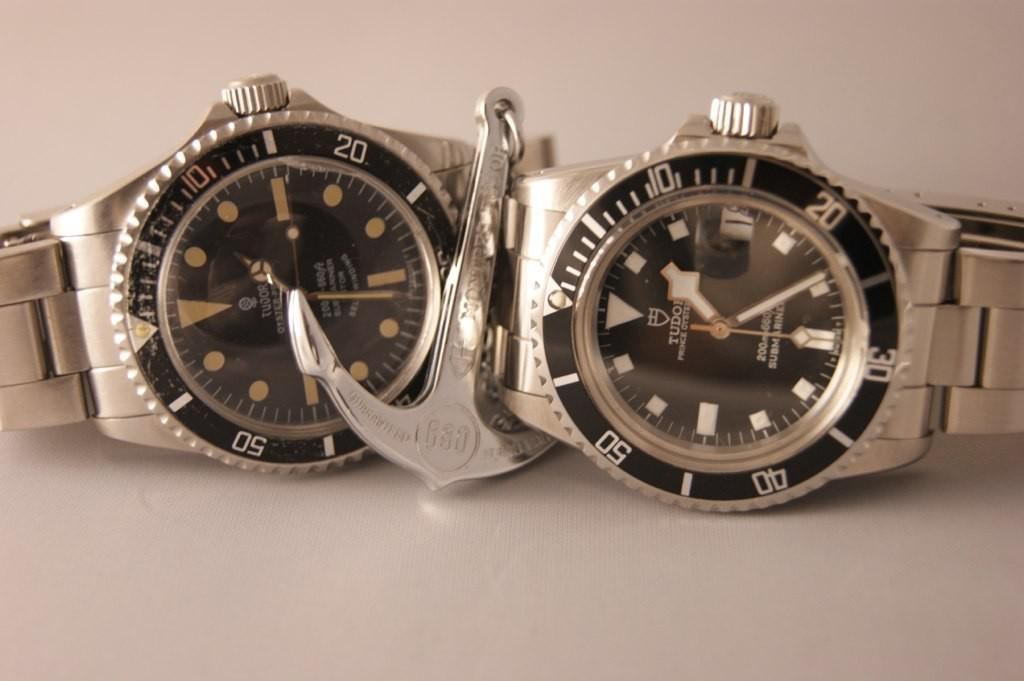Provide a one-sentence caption for the provided image. Two watches next to one another with one saying TUDOR on it. 